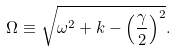Convert formula to latex. <formula><loc_0><loc_0><loc_500><loc_500>\Omega \equiv \sqrt { \omega ^ { 2 } + k - \left ( \frac { \gamma } { 2 } \right ) ^ { 2 } } .</formula> 